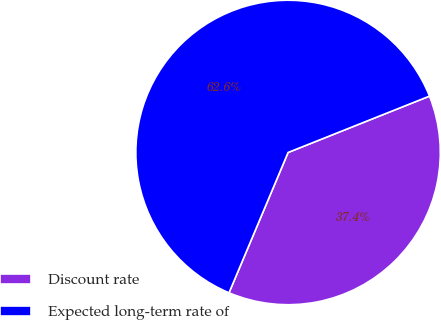Convert chart. <chart><loc_0><loc_0><loc_500><loc_500><pie_chart><fcel>Discount rate<fcel>Expected long-term rate of<nl><fcel>37.38%<fcel>62.62%<nl></chart> 